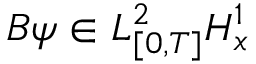<formula> <loc_0><loc_0><loc_500><loc_500>B \psi \in L _ { [ 0 , T ] } ^ { 2 } H _ { x } ^ { 1 }</formula> 